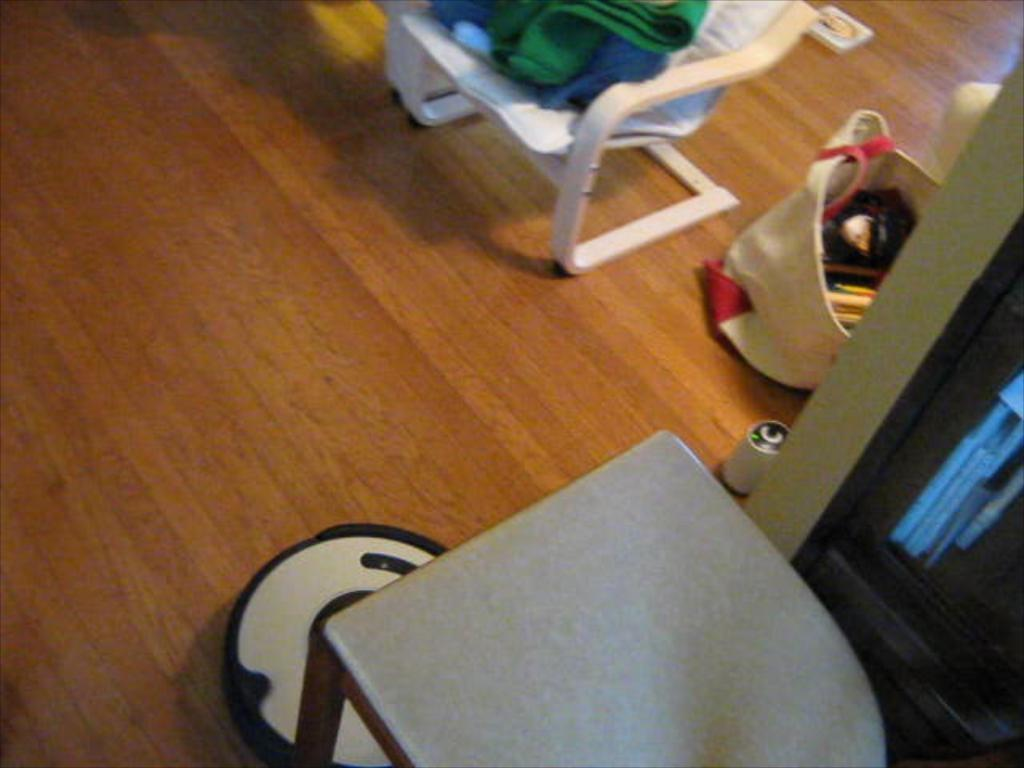What can be seen in the foreground of the image? There are objects in the foreground of the image. Where is the bag containing items located in the image? The bag containing items is on the right side of the image. What type of furniture is present in the image? There is a chair in the image. Can you describe any other objects present in the image? There are other objects present in the image, but their specific details are not mentioned in the provided facts. What type of zinc is present in the image? There is no mention of zinc in the provided facts, so it cannot be determined if any zinc is present in the image. Can you describe the haircut of the person in the image? There is no person present in the image, so it is not possible to describe their haircut. 